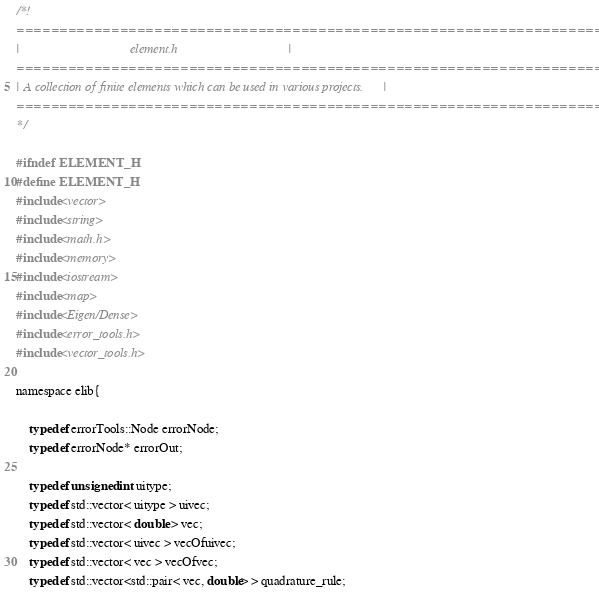<code> <loc_0><loc_0><loc_500><loc_500><_C_>/*!
===============================================================================
|                                  element.h                                  |
===============================================================================
| A collection of finite elements which can be used in various projects.      |
===============================================================================
*/

#ifndef ELEMENT_H
#define ELEMENT_H
#include<vector>
#include<string>
#include<math.h>
#include<memory>
#include<iostream>
#include<map>
#include<Eigen/Dense>
#include<error_tools.h>
#include<vector_tools.h>

namespace elib{

    typedef errorTools::Node errorNode;
    typedef errorNode* errorOut;

    typedef unsigned int uitype;
    typedef std::vector< uitype > uivec;
    typedef std::vector< double > vec;
    typedef std::vector< uivec > vecOfuivec;
    typedef std::vector< vec > vecOfvec;
    typedef std::vector<std::pair< vec, double> > quadrature_rule;
</code> 